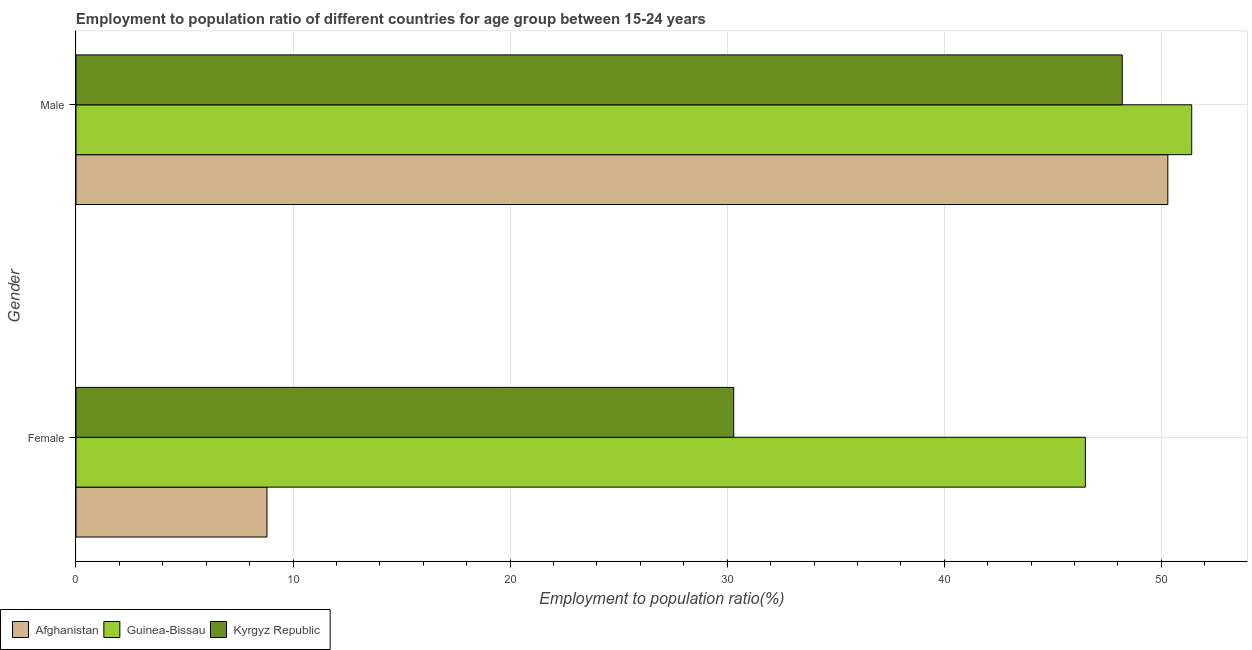How many different coloured bars are there?
Ensure brevity in your answer.  3. How many groups of bars are there?
Make the answer very short. 2. Are the number of bars per tick equal to the number of legend labels?
Your answer should be very brief. Yes. Are the number of bars on each tick of the Y-axis equal?
Keep it short and to the point. Yes. How many bars are there on the 1st tick from the top?
Make the answer very short. 3. What is the label of the 1st group of bars from the top?
Provide a short and direct response. Male. What is the employment to population ratio(female) in Guinea-Bissau?
Keep it short and to the point. 46.5. Across all countries, what is the maximum employment to population ratio(male)?
Offer a terse response. 51.4. Across all countries, what is the minimum employment to population ratio(female)?
Make the answer very short. 8.8. In which country was the employment to population ratio(female) maximum?
Offer a very short reply. Guinea-Bissau. In which country was the employment to population ratio(male) minimum?
Your answer should be very brief. Kyrgyz Republic. What is the total employment to population ratio(male) in the graph?
Your answer should be very brief. 149.9. What is the difference between the employment to population ratio(male) in Kyrgyz Republic and that in Afghanistan?
Your answer should be very brief. -2.1. What is the difference between the employment to population ratio(male) in Kyrgyz Republic and the employment to population ratio(female) in Afghanistan?
Provide a succinct answer. 39.4. What is the average employment to population ratio(male) per country?
Offer a terse response. 49.97. What is the difference between the employment to population ratio(male) and employment to population ratio(female) in Afghanistan?
Offer a terse response. 41.5. What is the ratio of the employment to population ratio(male) in Guinea-Bissau to that in Kyrgyz Republic?
Make the answer very short. 1.07. Is the employment to population ratio(female) in Afghanistan less than that in Kyrgyz Republic?
Your response must be concise. Yes. In how many countries, is the employment to population ratio(male) greater than the average employment to population ratio(male) taken over all countries?
Give a very brief answer. 2. What does the 3rd bar from the top in Female represents?
Your answer should be very brief. Afghanistan. What does the 3rd bar from the bottom in Male represents?
Ensure brevity in your answer.  Kyrgyz Republic. Are all the bars in the graph horizontal?
Your answer should be very brief. Yes. What is the difference between two consecutive major ticks on the X-axis?
Offer a terse response. 10. Does the graph contain any zero values?
Your answer should be very brief. No. Where does the legend appear in the graph?
Offer a very short reply. Bottom left. How many legend labels are there?
Provide a succinct answer. 3. How are the legend labels stacked?
Your answer should be very brief. Horizontal. What is the title of the graph?
Ensure brevity in your answer.  Employment to population ratio of different countries for age group between 15-24 years. Does "Samoa" appear as one of the legend labels in the graph?
Your response must be concise. No. What is the label or title of the Y-axis?
Offer a very short reply. Gender. What is the Employment to population ratio(%) of Afghanistan in Female?
Give a very brief answer. 8.8. What is the Employment to population ratio(%) in Guinea-Bissau in Female?
Give a very brief answer. 46.5. What is the Employment to population ratio(%) in Kyrgyz Republic in Female?
Offer a very short reply. 30.3. What is the Employment to population ratio(%) of Afghanistan in Male?
Ensure brevity in your answer.  50.3. What is the Employment to population ratio(%) of Guinea-Bissau in Male?
Your response must be concise. 51.4. What is the Employment to population ratio(%) of Kyrgyz Republic in Male?
Your response must be concise. 48.2. Across all Gender, what is the maximum Employment to population ratio(%) in Afghanistan?
Keep it short and to the point. 50.3. Across all Gender, what is the maximum Employment to population ratio(%) in Guinea-Bissau?
Provide a succinct answer. 51.4. Across all Gender, what is the maximum Employment to population ratio(%) of Kyrgyz Republic?
Ensure brevity in your answer.  48.2. Across all Gender, what is the minimum Employment to population ratio(%) of Afghanistan?
Your answer should be compact. 8.8. Across all Gender, what is the minimum Employment to population ratio(%) in Guinea-Bissau?
Make the answer very short. 46.5. Across all Gender, what is the minimum Employment to population ratio(%) in Kyrgyz Republic?
Provide a short and direct response. 30.3. What is the total Employment to population ratio(%) of Afghanistan in the graph?
Your response must be concise. 59.1. What is the total Employment to population ratio(%) of Guinea-Bissau in the graph?
Provide a short and direct response. 97.9. What is the total Employment to population ratio(%) of Kyrgyz Republic in the graph?
Your answer should be compact. 78.5. What is the difference between the Employment to population ratio(%) in Afghanistan in Female and that in Male?
Make the answer very short. -41.5. What is the difference between the Employment to population ratio(%) of Kyrgyz Republic in Female and that in Male?
Your answer should be compact. -17.9. What is the difference between the Employment to population ratio(%) of Afghanistan in Female and the Employment to population ratio(%) of Guinea-Bissau in Male?
Make the answer very short. -42.6. What is the difference between the Employment to population ratio(%) of Afghanistan in Female and the Employment to population ratio(%) of Kyrgyz Republic in Male?
Your response must be concise. -39.4. What is the difference between the Employment to population ratio(%) in Guinea-Bissau in Female and the Employment to population ratio(%) in Kyrgyz Republic in Male?
Provide a succinct answer. -1.7. What is the average Employment to population ratio(%) in Afghanistan per Gender?
Your response must be concise. 29.55. What is the average Employment to population ratio(%) of Guinea-Bissau per Gender?
Offer a terse response. 48.95. What is the average Employment to population ratio(%) of Kyrgyz Republic per Gender?
Offer a terse response. 39.25. What is the difference between the Employment to population ratio(%) of Afghanistan and Employment to population ratio(%) of Guinea-Bissau in Female?
Your answer should be very brief. -37.7. What is the difference between the Employment to population ratio(%) in Afghanistan and Employment to population ratio(%) in Kyrgyz Republic in Female?
Your answer should be very brief. -21.5. What is the difference between the Employment to population ratio(%) of Guinea-Bissau and Employment to population ratio(%) of Kyrgyz Republic in Female?
Make the answer very short. 16.2. What is the ratio of the Employment to population ratio(%) in Afghanistan in Female to that in Male?
Keep it short and to the point. 0.17. What is the ratio of the Employment to population ratio(%) in Guinea-Bissau in Female to that in Male?
Provide a short and direct response. 0.9. What is the ratio of the Employment to population ratio(%) in Kyrgyz Republic in Female to that in Male?
Your response must be concise. 0.63. What is the difference between the highest and the second highest Employment to population ratio(%) of Afghanistan?
Your response must be concise. 41.5. What is the difference between the highest and the second highest Employment to population ratio(%) of Kyrgyz Republic?
Your response must be concise. 17.9. What is the difference between the highest and the lowest Employment to population ratio(%) of Afghanistan?
Keep it short and to the point. 41.5. What is the difference between the highest and the lowest Employment to population ratio(%) of Guinea-Bissau?
Your response must be concise. 4.9. 